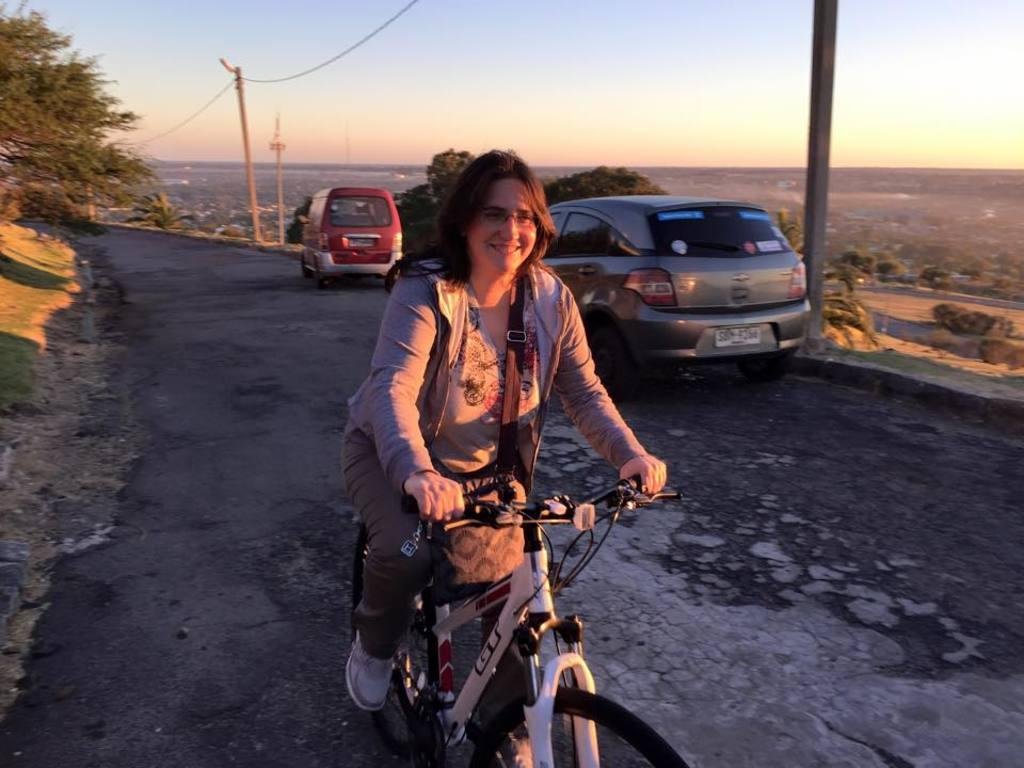What is the woman doing in the image? The woman is on a bicycle in the image. What can be seen in the background of the image? There are trees and electric poles visible in the background of the image. What is the road used for in the image? The road is used by cars in the image. Can you describe the setting of the image? The image shows a woman on a bicycle on a road with trees and electric poles in the background. What type of business is the woman conducting in the image? There is no indication of a business transaction or activity in the image. 